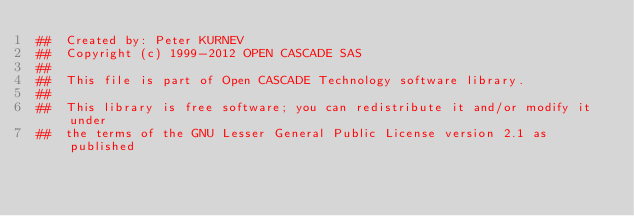<code> <loc_0><loc_0><loc_500><loc_500><_Nim_>##  Created by: Peter KURNEV
##  Copyright (c) 1999-2012 OPEN CASCADE SAS
##
##  This file is part of Open CASCADE Technology software library.
##
##  This library is free software; you can redistribute it and/or modify it under
##  the terms of the GNU Lesser General Public License version 2.1 as published</code> 